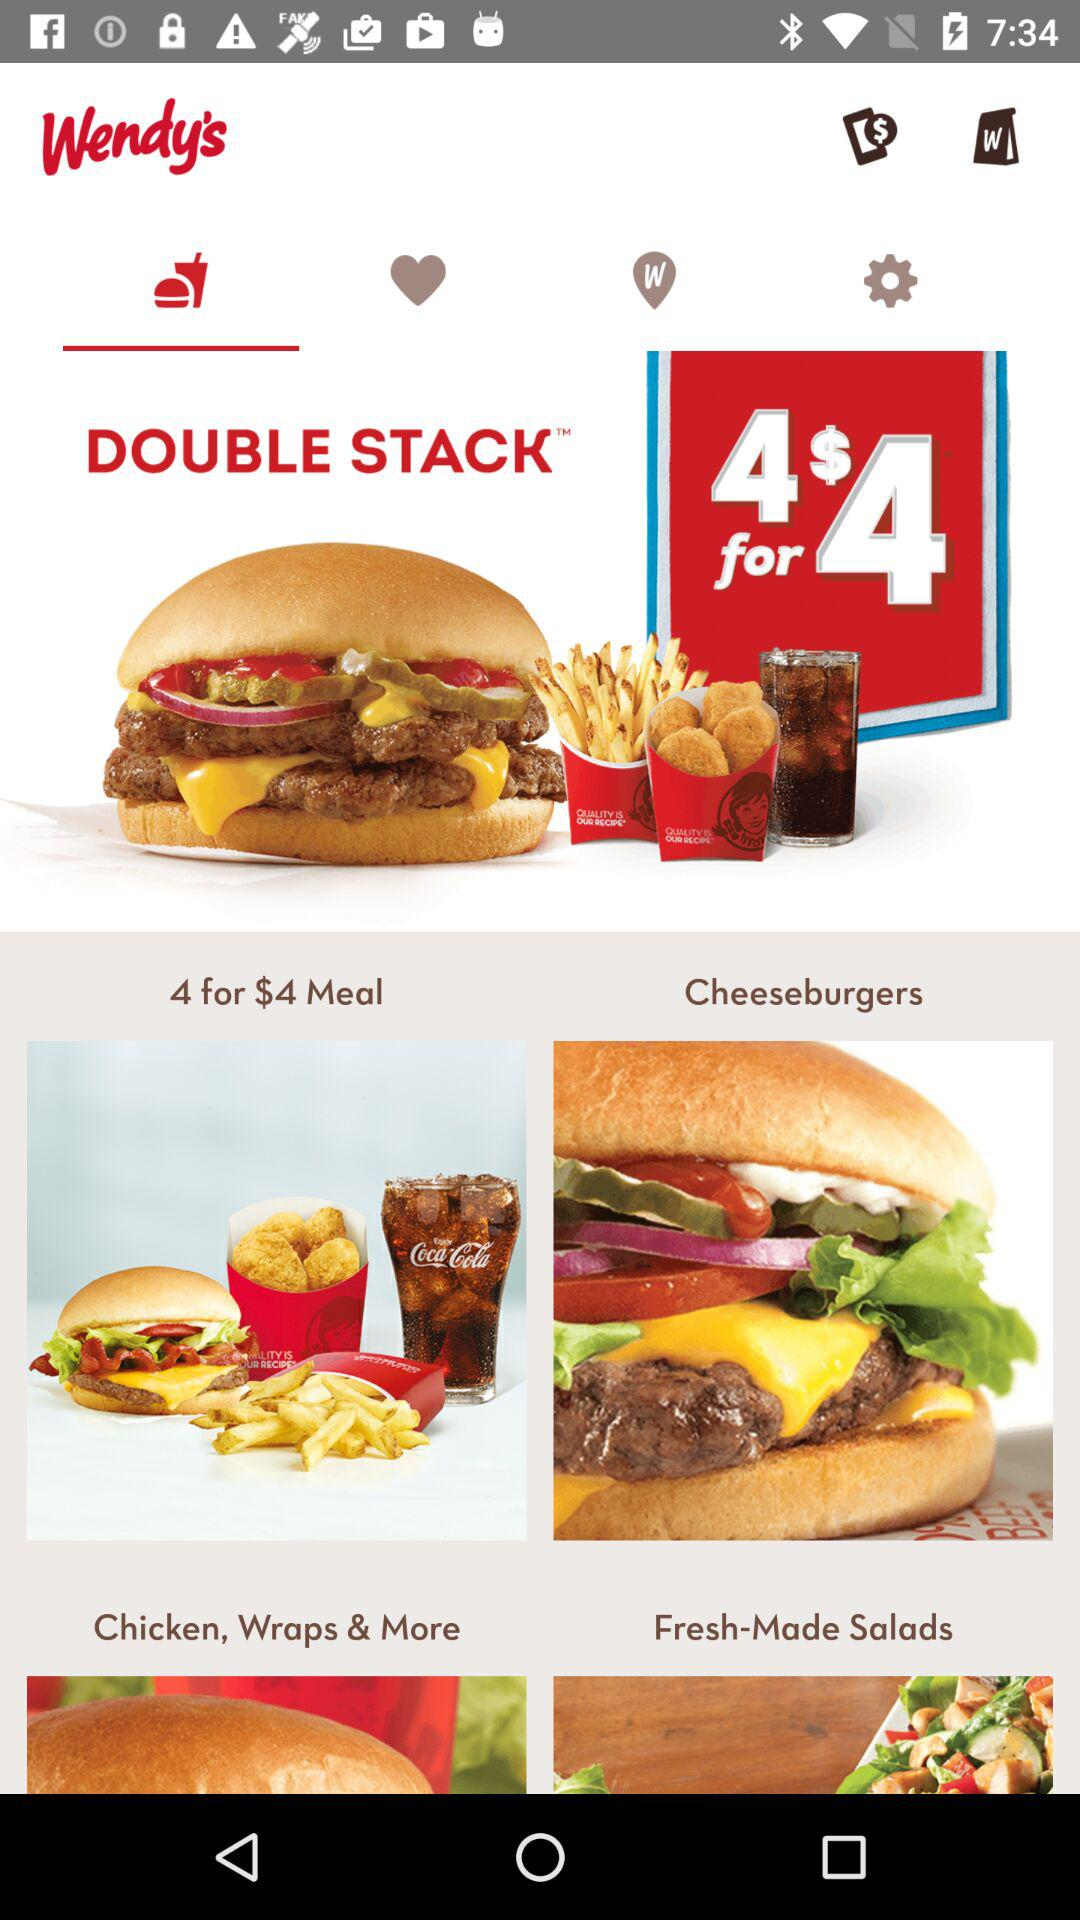What is the price of the "DOUBLE STACK" meal? The price of the "DOUBLE STACK" meal is $4. 